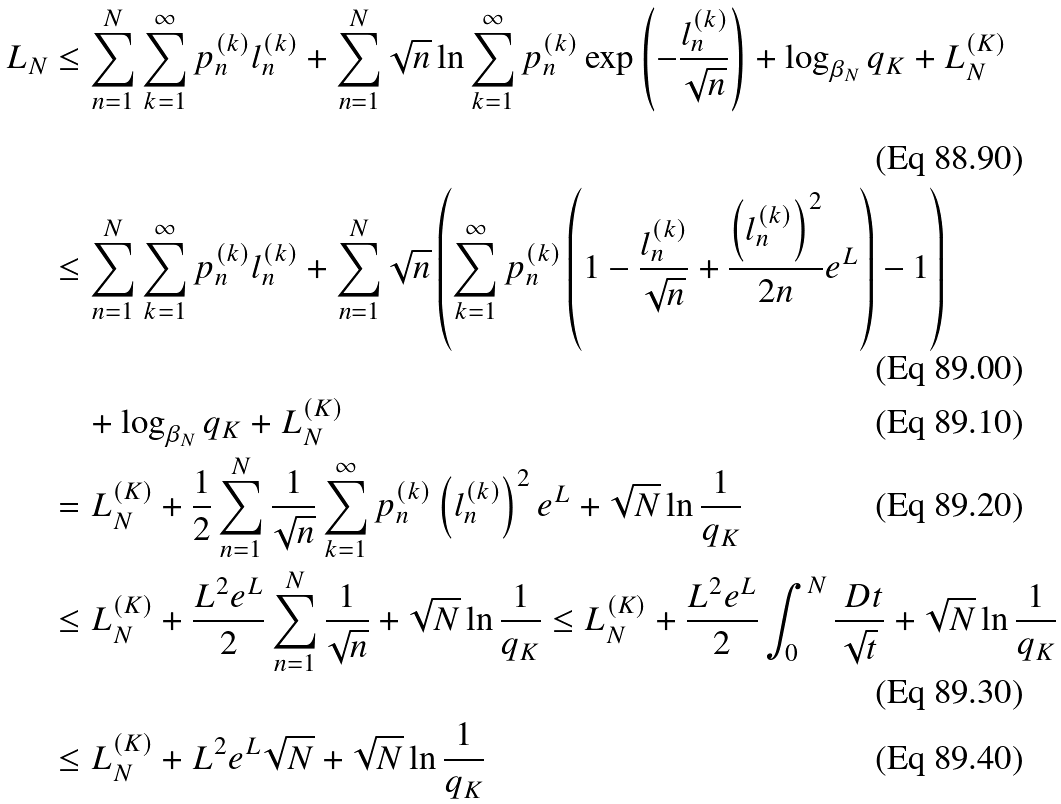Convert formula to latex. <formula><loc_0><loc_0><loc_500><loc_500>L _ { N } & \leq \sum _ { n = 1 } ^ { N } \sum _ { k = 1 } ^ { \infty } p _ { n } ^ { ( k ) } l _ { n } ^ { ( k ) } + \sum _ { n = 1 } ^ { N } \sqrt { n } \ln \sum _ { k = 1 } ^ { \infty } p _ { n } ^ { ( k ) } \exp \left ( - \frac { l _ { n } ^ { ( k ) } } { \sqrt { n } } \right ) + \log _ { \beta _ { N } } q _ { K } + L _ { N } ^ { ( K ) } \\ & \leq \sum _ { n = 1 } ^ { N } \sum _ { k = 1 } ^ { \infty } p _ { n } ^ { ( k ) } l _ { n } ^ { ( k ) } + \sum _ { n = 1 } ^ { N } \sqrt { n } \left ( \sum _ { k = 1 } ^ { \infty } p _ { n } ^ { ( k ) } \left ( 1 - \frac { l _ { n } ^ { ( k ) } } { \sqrt { n } } + \frac { \left ( l _ { n } ^ { ( k ) } \right ) ^ { 2 } } { 2 n } e ^ { L } \right ) - 1 \right ) \\ & \quad + \log _ { \beta _ { N } } q _ { K } + L _ { N } ^ { ( K ) } \\ & = L _ { N } ^ { ( K ) } + \frac { 1 } { 2 } \sum _ { n = 1 } ^ { N } \frac { 1 } { \sqrt { n } } \sum _ { k = 1 } ^ { \infty } p _ { n } ^ { ( k ) } \left ( l _ { n } ^ { ( k ) } \right ) ^ { 2 } e ^ { L } + \sqrt { N } \ln \frac { 1 } { q _ { K } } \\ & \leq L _ { N } ^ { ( K ) } + \frac { L ^ { 2 } e ^ { L } } { 2 } \sum _ { n = 1 } ^ { N } \frac { 1 } { \sqrt { n } } + \sqrt { N } \ln \frac { 1 } { q _ { K } } \leq L _ { N } ^ { ( K ) } + \frac { L ^ { 2 } e ^ { L } } { 2 } \int _ { 0 } ^ { N } \frac { \ D t } { \sqrt { t } } + \sqrt { N } \ln \frac { 1 } { q _ { K } } \\ & \leq L _ { N } ^ { ( K ) } + L ^ { 2 } e ^ { L } \sqrt { N } + \sqrt { N } \ln \frac { 1 } { q _ { K } }</formula> 